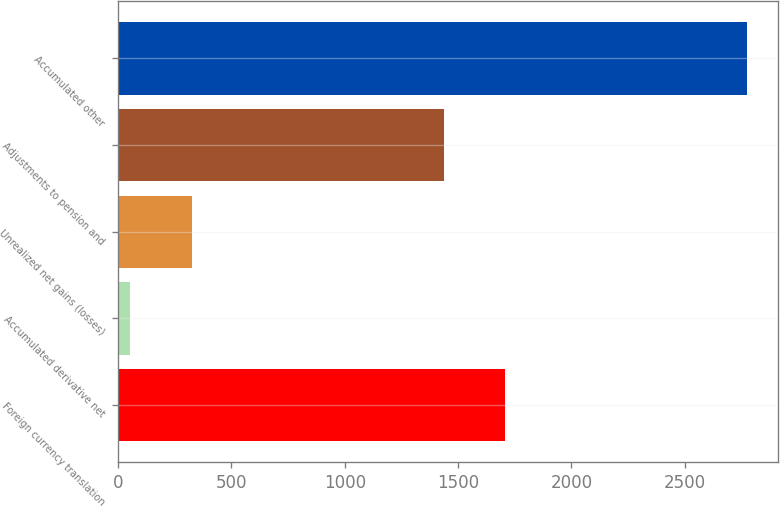Convert chart to OTSL. <chart><loc_0><loc_0><loc_500><loc_500><bar_chart><fcel>Foreign currency translation<fcel>Accumulated derivative net<fcel>Unrealized net gains (losses)<fcel>Adjustments to pension and<fcel>Accumulated other<nl><fcel>1708.1<fcel>53<fcel>325.1<fcel>1436<fcel>2774<nl></chart> 